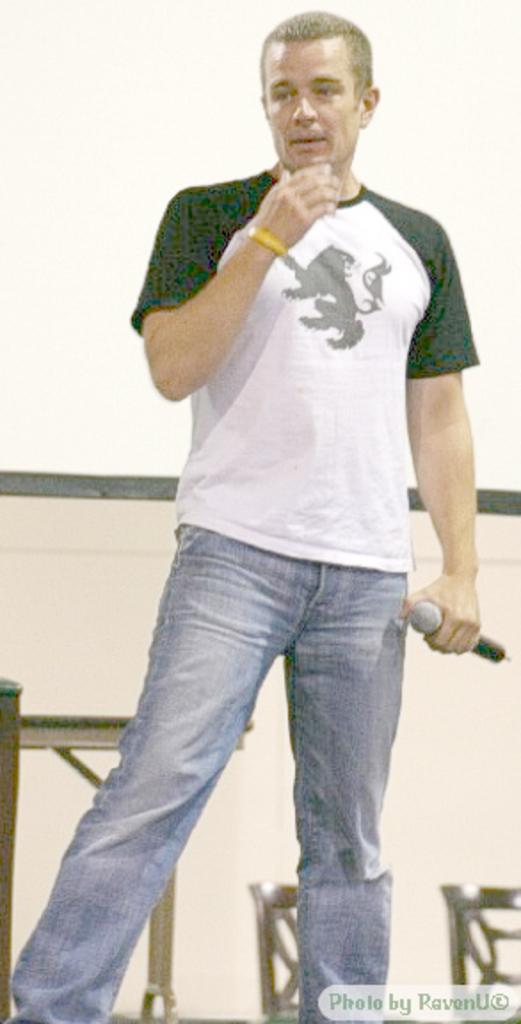How would you summarize this image in a sentence or two? In this image we can see a person standing and holding a mike. Back of him there are chairs. 